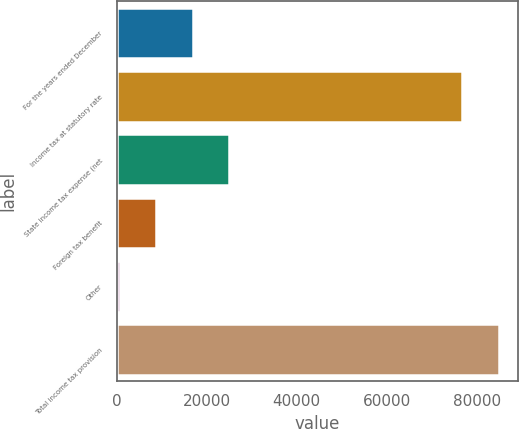<chart> <loc_0><loc_0><loc_500><loc_500><bar_chart><fcel>For the years ended December<fcel>Income tax at statutory rate<fcel>State income tax expense (net<fcel>Foreign tax benefit<fcel>Other<fcel>Total income tax provision<nl><fcel>16899.2<fcel>76820<fcel>25014.3<fcel>8784.1<fcel>669<fcel>84935.1<nl></chart> 